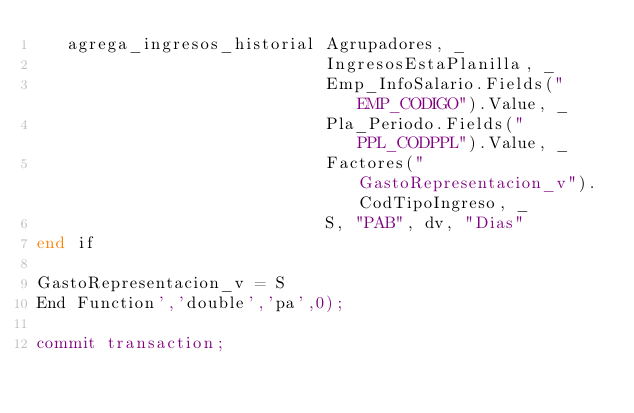Convert code to text. <code><loc_0><loc_0><loc_500><loc_500><_SQL_>   agrega_ingresos_historial Agrupadores, _
                             IngresosEstaPlanilla, _
                             Emp_InfoSalario.Fields("EMP_CODIGO").Value, _
                             Pla_Periodo.Fields("PPL_CODPPL").Value, _
                             Factores("GastoRepresentacion_v").CodTipoIngreso, _
                             S, "PAB", dv, "Dias"
end if

GastoRepresentacion_v = S
End Function','double','pa',0);

commit transaction;
</code> 